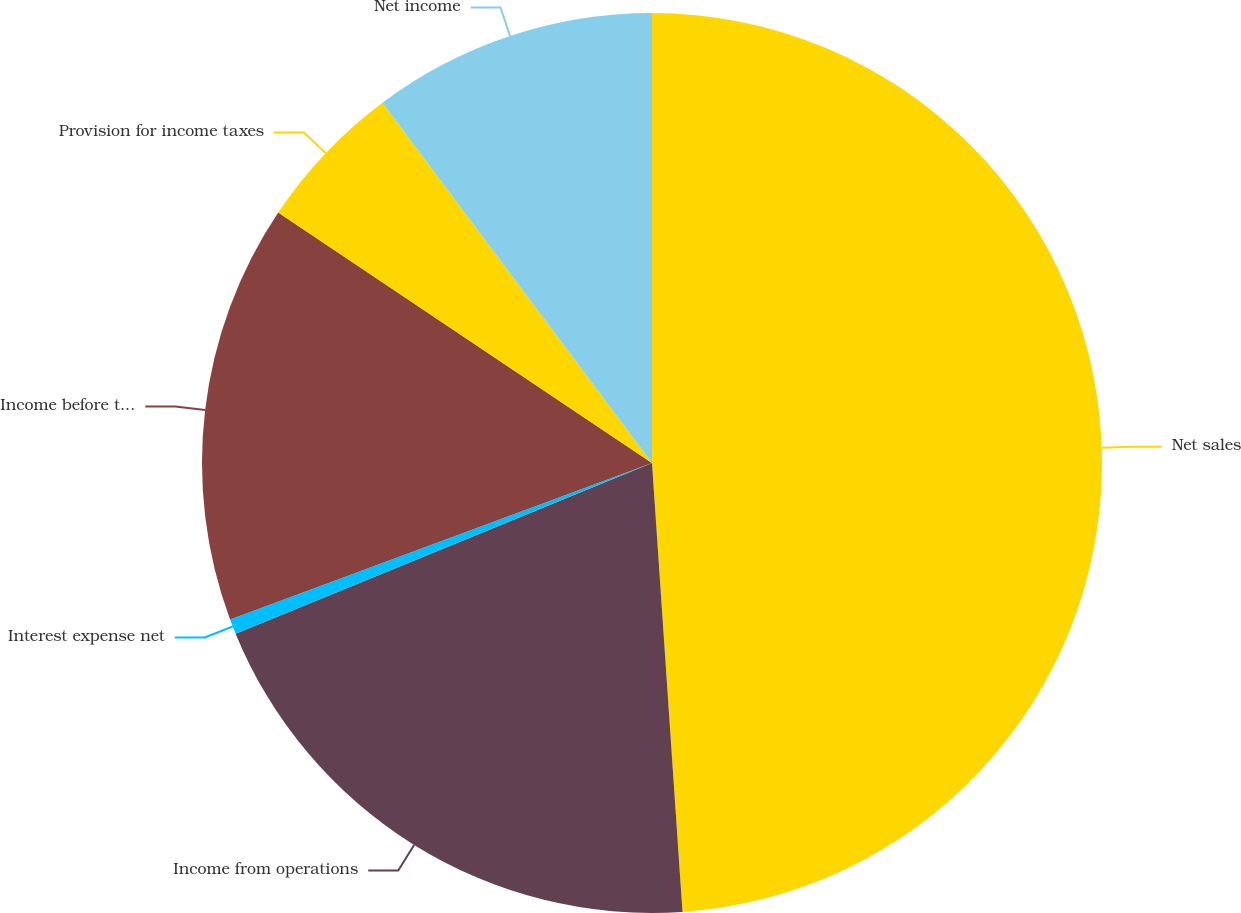Convert chart. <chart><loc_0><loc_0><loc_500><loc_500><pie_chart><fcel>Net sales<fcel>Income from operations<fcel>Interest expense net<fcel>Income before taxes<fcel>Provision for income taxes<fcel>Net income<nl><fcel>48.92%<fcel>19.89%<fcel>0.54%<fcel>15.05%<fcel>5.38%<fcel>10.22%<nl></chart> 